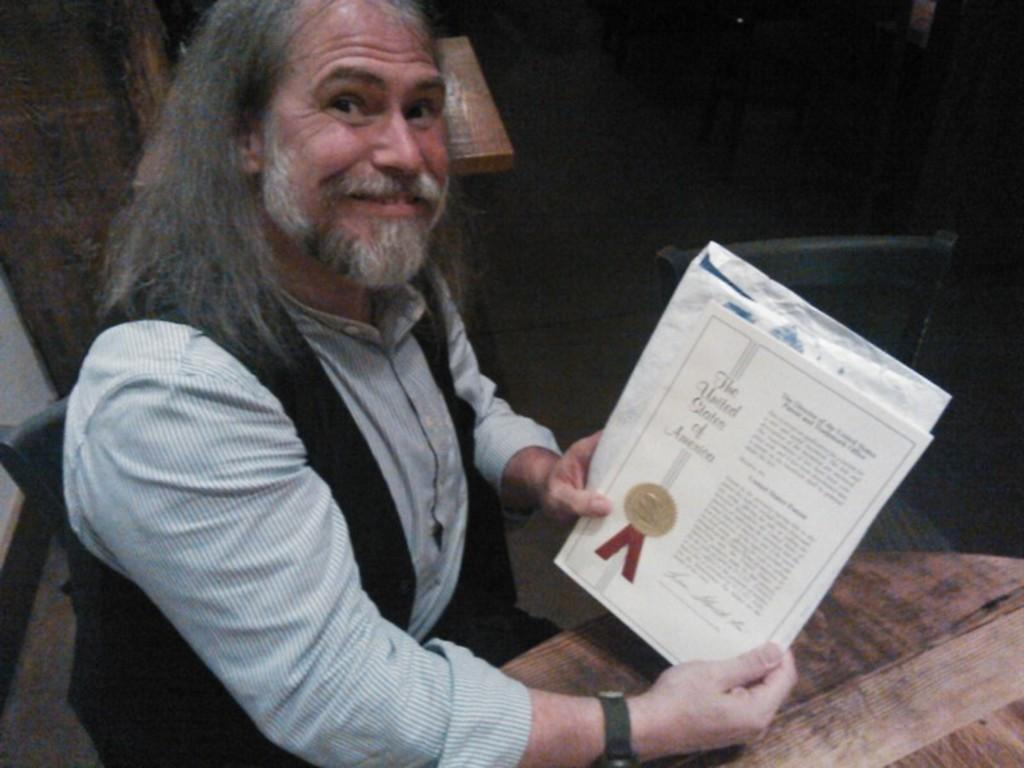What is the man in the image doing? The man is sitting in the image. What is the man holding in his hand? The man is holding a certificate in his hand. What is in front of the man? There is a table in front of the man. What can be seen in the background of the image? There is a chair and a wall in the background of the image. What type of ear is visible on the man's face in the image? There is no ear visible on the man's face in the image. What territory is the man claiming in the image? There is no territory being claimed in the image; it is a man sitting and holding a certificate. 